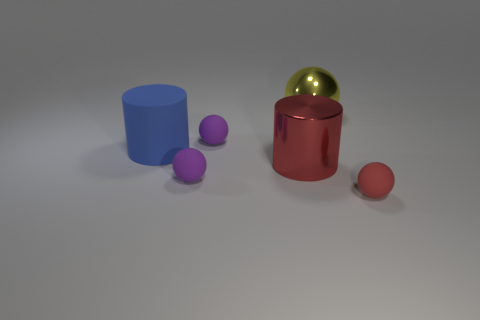There is a large red object that is the same shape as the large blue object; what is it made of?
Your answer should be very brief. Metal. Is there anything else that has the same material as the big red cylinder?
Give a very brief answer. Yes. Is the material of the tiny red sphere the same as the blue cylinder to the left of the big yellow thing?
Your answer should be very brief. Yes. The big blue object behind the big metal object that is in front of the yellow thing is what shape?
Your answer should be very brief. Cylinder. How many large objects are red shiny objects or yellow objects?
Provide a short and direct response. 2. What number of yellow shiny objects have the same shape as the large blue thing?
Your response must be concise. 0. There is a blue object; is it the same shape as the red object that is behind the tiny red matte sphere?
Give a very brief answer. Yes. What number of objects are to the right of the small red ball?
Provide a short and direct response. 0. Is there a blue rubber cylinder of the same size as the blue rubber thing?
Provide a short and direct response. No. Is the shape of the large red object that is to the right of the blue matte cylinder the same as  the small red thing?
Keep it short and to the point. No. 